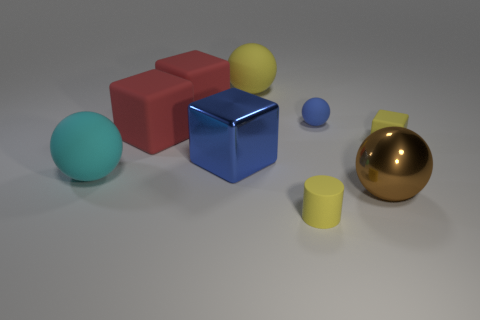Add 1 red cubes. How many objects exist? 10 Subtract all blocks. How many objects are left? 5 Subtract 1 cyan balls. How many objects are left? 8 Subtract all cylinders. Subtract all metal blocks. How many objects are left? 7 Add 6 large yellow objects. How many large yellow objects are left? 7 Add 6 tiny yellow cubes. How many tiny yellow cubes exist? 7 